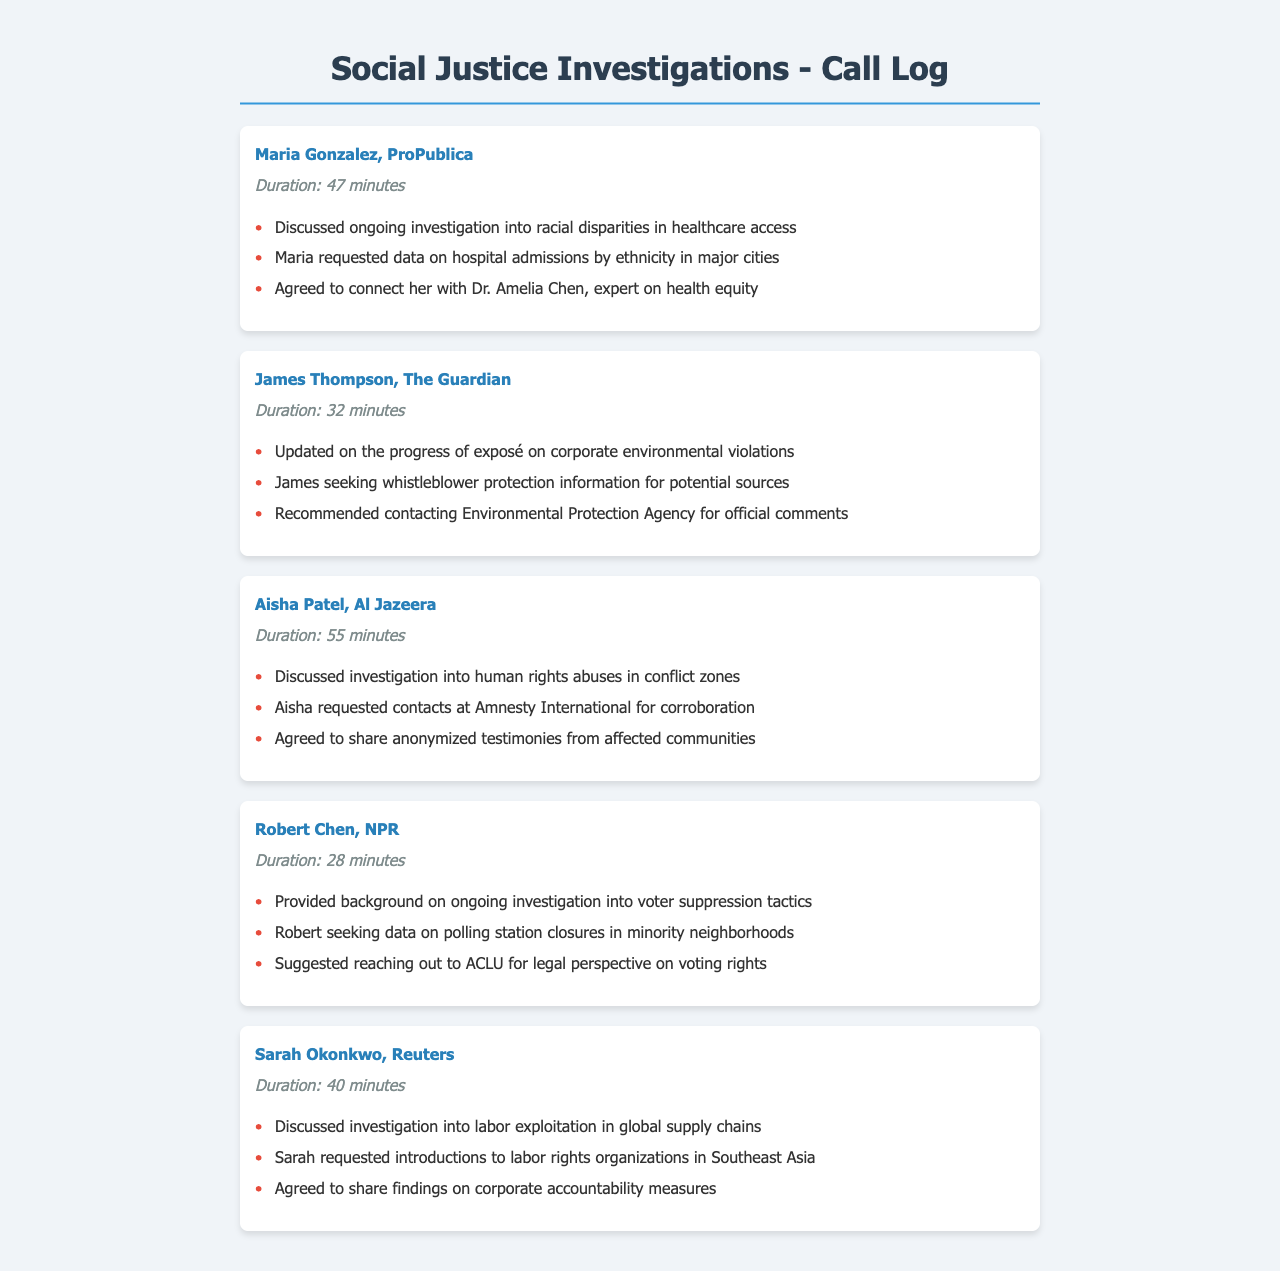What is the duration of the call with Maria Gonzalez? The duration of the call with Maria Gonzalez is stated as 47 minutes in the document.
Answer: 47 minutes Who is the contact for the investigation into labor exploitation? The document identifies Sarah Okonkwo from Reuters as the contact discussing labor exploitation in global supply chains.
Answer: Sarah Okonkwo What organization did Aisha Patel request contacts from? Aisha Patel requested contacts at Amnesty International for corroboration, as indicated in the call log.
Answer: Amnesty International What is the focus of the investigation discussed with Robert Chen? The focus of the investigation discussed with Robert Chen is voter suppression tactics, as noted in the document.
Answer: Voter suppression tactics How long was the call with James Thompson? The duration of the call with James Thompson is listed as 32 minutes in the call log.
Answer: 32 minutes Which journalist is investigating human rights abuses? Aisha Patel from Al Jazeera is investigating human rights abuses in conflict zones, according to the document.
Answer: Aisha Patel What data did Maria request related to healthcare? Maria requested data on hospital admissions by ethnicity in major cities, as stated in the call log.
Answer: Hospital admissions by ethnicity Which agency was recommended for contacting regarding corporate environmental violations? The document mentions the Environmental Protection Agency as the recommended agency for official comments on corporate environmental violations.
Answer: Environmental Protection Agency What did Sarah agree to share regarding corporate accountability? Sarah agreed to share findings on corporate accountability measures, as noted in her call log entry.
Answer: Corporate accountability measures 